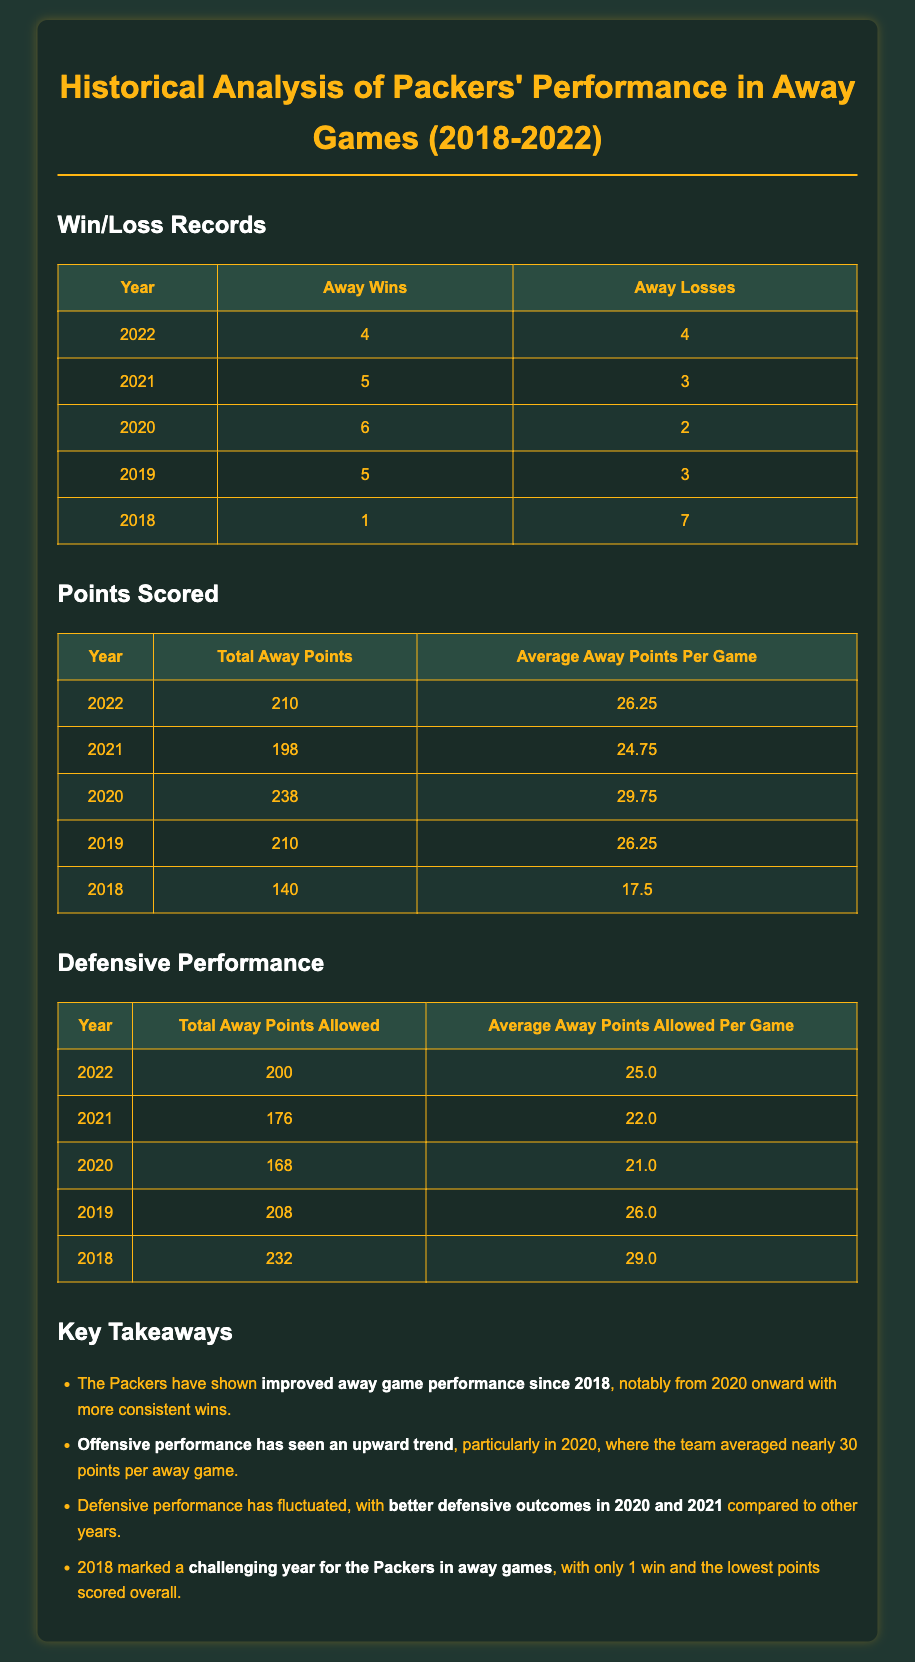What was the Packers' away win total in 2022? The document provides a table of win/loss records for each year, with 2022 showing 4 away wins.
Answer: 4 What was the average points scored per away game in 2020? The document lists average away points per game for each year, indicating 2020 had an average of 29.75 points.
Answer: 29.75 How many away losses did the Packers have in 2018? The win/loss records table specifies that in 2018, the Packers had 7 away losses.
Answer: 7 What is the total points allowed by the Packers in away games in 2021? The defensive performance section shows that 2021's total away points allowed was 176.
Answer: 176 Which year had the lowest average points scored per away game? By comparing the average points scored across all years, 2018 has the lowest average at 17.5 points per game.
Answer: 17.5 What key trend is noted about the Packers' defensive performance? The key takeaways section highlights that defensive performance improved in the years 2020 and 2021 compared to others.
Answer: Improved What was the Packers’ total away points scored in 2019? The points scored table indicates that in 2019, they scored a total of 210 away points.
Answer: 210 In which year did the Packers have the highest number of away wins? Looking at the win/loss records, 2020 had the highest number of away wins at 6.
Answer: 6 What significant performance change occurred from 2018 to 2022? The analysis mentions that there was a notable improvement in away game performance, specifically in terms of wins.
Answer: Improvement 